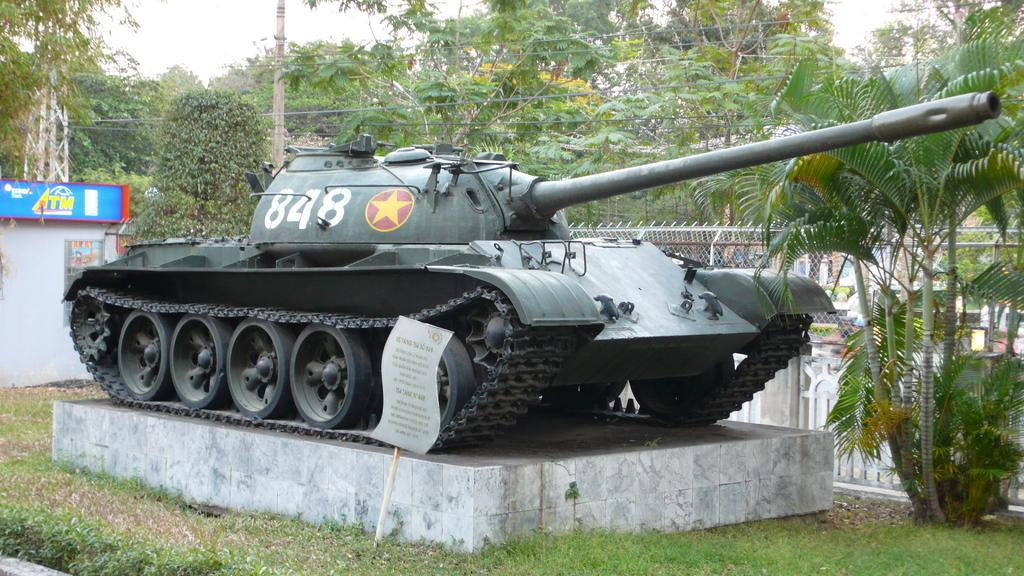What type of vegetation can be seen in the image? There is grass in the image. What type of vehicle is present in the image? There is a military vehicle in the image. What objects are made of wood in the image? There are boards in the image. What type of barrier is present in the image? There is a fence in the image. What tall, thin object can be seen in the image? There is a pole in the image. What type of plant is visible in the image besides grass? There are trees in the image. What part of the natural environment is visible in the background of the image? The sky is visible in the background of the image. How does the example of a necklace appear in the image? There is no necklace present in the image. How does the walkway look like in the image? There is no walkway mentioned in the provided facts, so it cannot be determined from the image. 